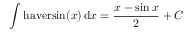<formula> <loc_0><loc_0><loc_500><loc_500>\int h a v e r \sin ( x ) \, d x = { \frac { x - \sin { x } } { 2 } } + C</formula> 